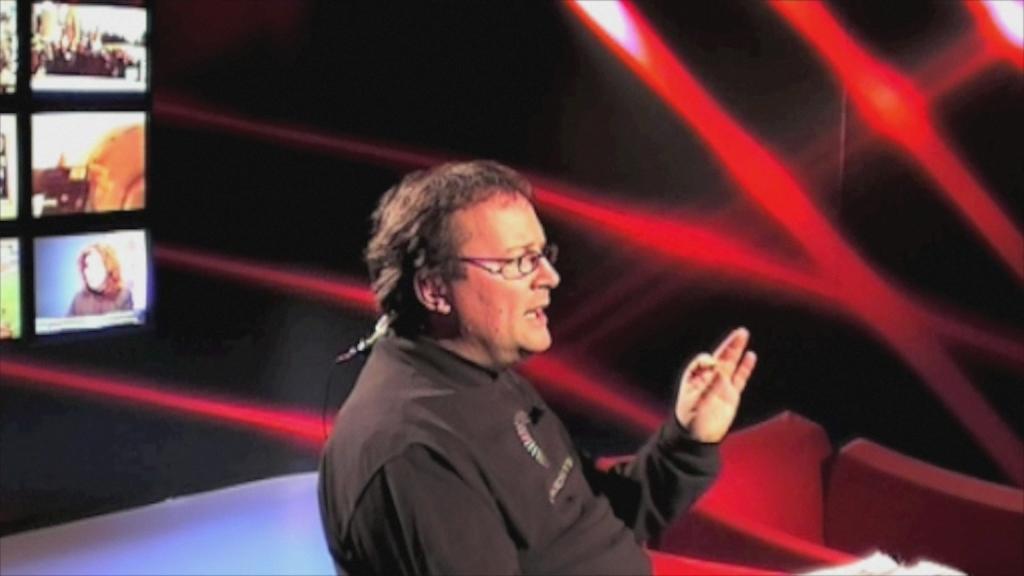Please provide a concise description of this image. In the image there is a man, he is speaking something and behind the man there are some pictures being displayed and beside that there is a red and black decoration in the background. 